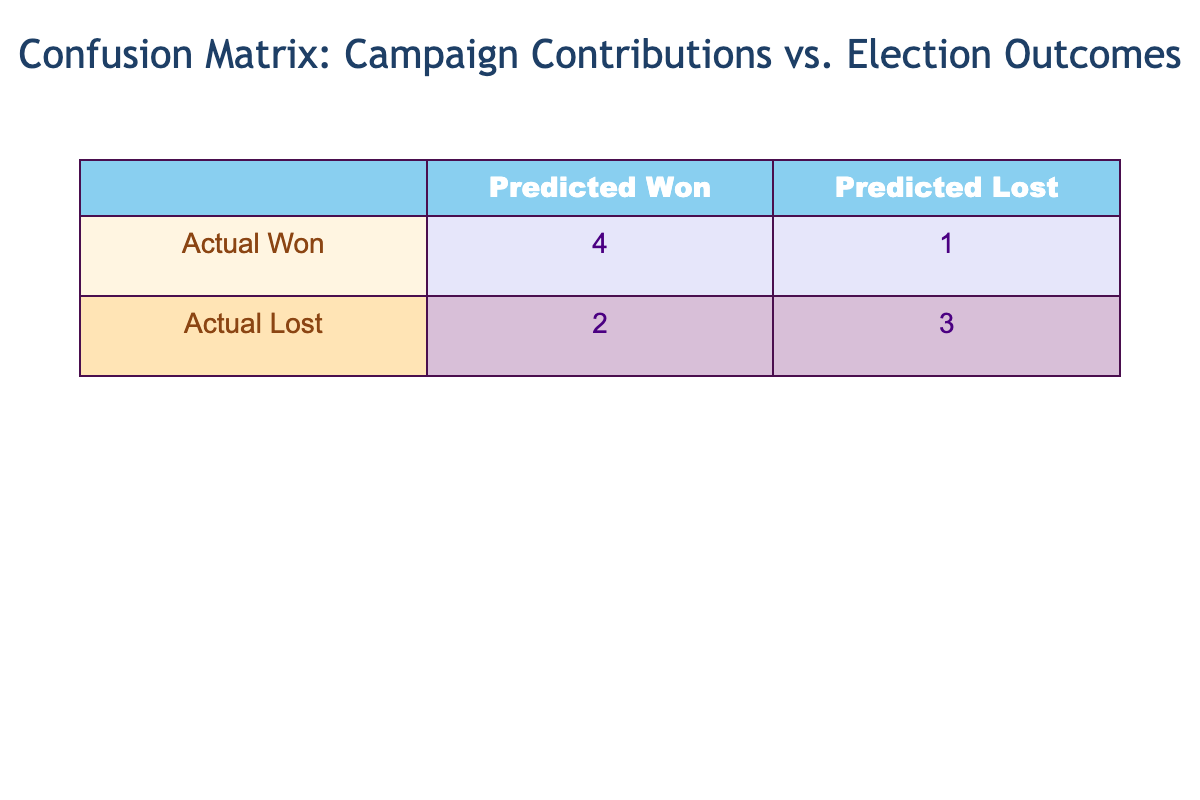What is the total number of candidates that were predicted to win? The table indicates the number of candidates predicted to win by looking at the "Predicted Outcome" column for the value "Won." From the table, there are four candidates: John Smith, Michael Johnson, Emily Davis, and Brian Clark.
Answer: 4 How many candidates actually lost according to the table? To determine this, we look at the "Election Outcome" column for the value "Lost." The candidates who lost are Jane Doe, Sarah Brown, David Lee, Chris White, and Sophia Taylor, totaling five candidates.
Answer: 5 What is the difference between the number of candidates who actually won and those who were predicted to win? First, count the candidates who won (actual winners: John Smith, Michael Johnson, Emily Davis, Olivia Green) which totals four. For predicted winners, we have also four candidates (same as above) since they were all correctly predicted. Thus, the difference is 4 - 4 = 0.
Answer: 0 Is it true that all independent candidates lost the election? There are two independent candidates listed: David Lee and Sophia Taylor, both of whom have "Lost" as their election outcome. Hence, it is true that all independent candidates lost the election.
Answer: Yes What percentage of candidates who were predicted to win actually won their elections? There are four candidates predicted to win and all of them actually won their elections: John Smith, Michael Johnson, Emily Davis, and Olivia Green. Therefore, the percentage calculated is (4/4)*100 = 100%.
Answer: 100% 